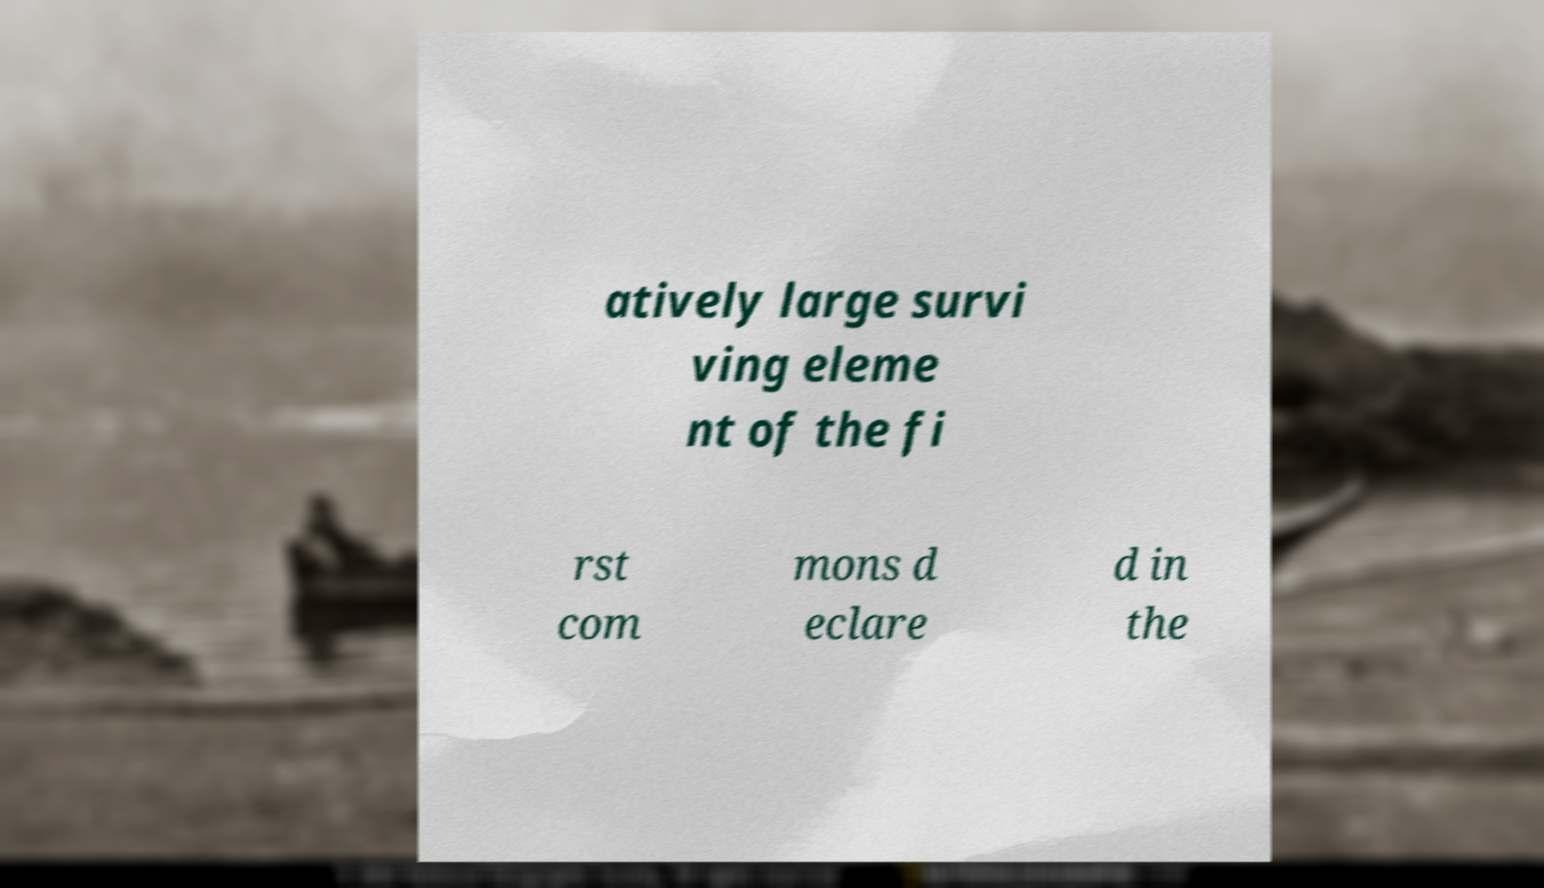What messages or text are displayed in this image? I need them in a readable, typed format. atively large survi ving eleme nt of the fi rst com mons d eclare d in the 